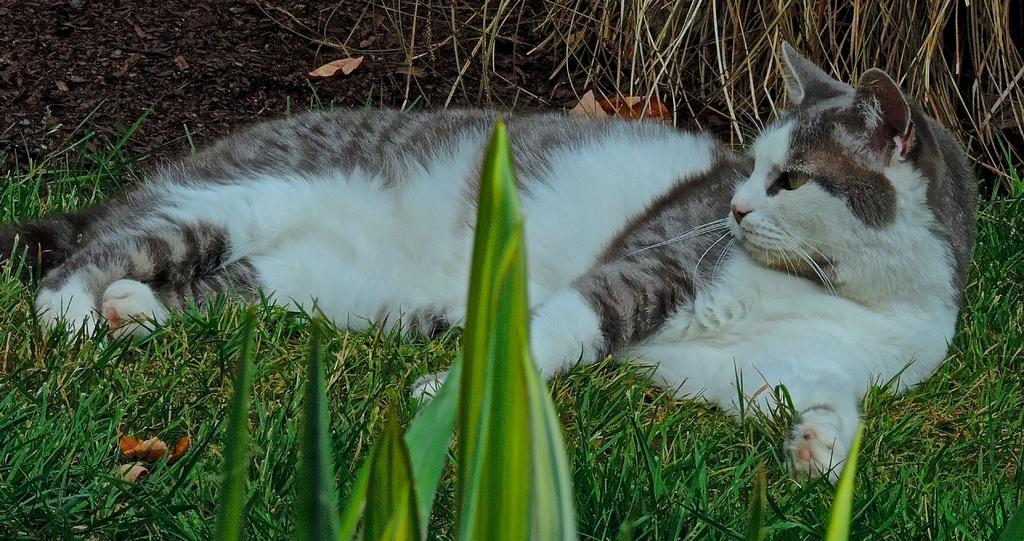What animal can be seen lying on the ground in the image? There is a cat lying on the ground in the center of the image. What type of terrain is visible at the top of the image? Dry grass is visible at the top of the image. What type of vegetation is present at the bottom of the image? Plants and grass are present at the bottom of the image. What type of degree does the rat in the image have? There is no rat present in the image, so it is not possible to determine what degree it might have. 